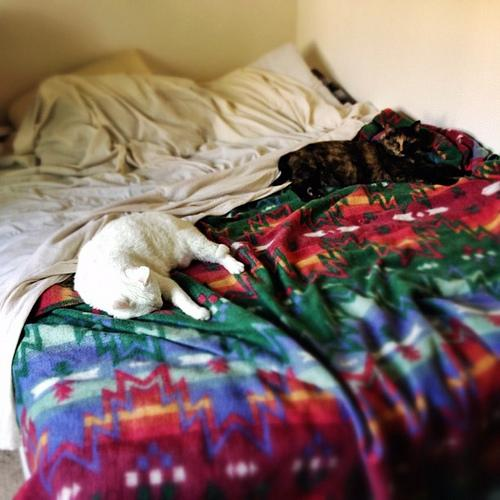Tell me about the main aspects of the bed's appearance. The bed has rumpled white bed sheets, two pillows, and a soft multi-colored blanket with a zigzag blue line and a yellow stripe. What are the two pets on the bed in the picture? There are two cats on the bed, one is an all-white cat relaxing, and the other is a tortoiseshell cat watching the photographer. State what time of day the photo appears to be taken in. The photo appears to be taken during the daytime. Describe the state of the pillows and bedspread on the bed. The pillows are rumpled and off-white in color, while the bedspread is pulled back, revealing the white sheets underneath. Give a brief description of the cats' fur colors and patterns. One cat has pure white fur, while the other has brown and black fur in a tortoiseshell pattern. Talk about the various hues and patterns visible in the picture. The image features a multicolored blanket with red, blue, green, yellow, and white, a yellow stripe between orange, and green and pink trees on the blanket. What can be inferred about the overall ambiance of the room? The room has a relaxed ambiance with two cats lounging on the bed, a colorful blanket, and cream-colored walls forming a corner. Tell me about the apparent actions or positions of the cats in the image. One cat is laying down and relaxing on the bed, while the other cat is facing the camera and watching the photographer. List the main components of the bed and their respective colors. The bed has rumpled white sheets, off-white pillows, a rainbow-colored blanket with zigzag blue and yellow stripes, and green and pink trees. Describe the colors and arrangement of the three boxes within the image. There are three white blocks between green and blue, and three blue boxes positioned near the white ones. 